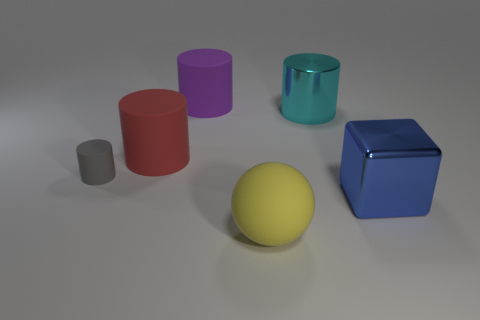Is there a big blue cube that has the same material as the large cyan cylinder?
Your answer should be very brief. Yes. The blue shiny object is what size?
Your answer should be compact. Large. What number of yellow objects are either large balls or tiny objects?
Make the answer very short. 1. What number of yellow rubber objects have the same shape as the red matte thing?
Ensure brevity in your answer.  0. How many green matte cylinders are the same size as the blue metal object?
Provide a succinct answer. 0. There is a purple object that is the same shape as the big red rubber object; what is its material?
Ensure brevity in your answer.  Rubber. There is a cylinder that is on the right side of the big purple thing; what color is it?
Provide a succinct answer. Cyan. Is the number of large shiny things behind the cyan object greater than the number of big red rubber cylinders?
Keep it short and to the point. No. What color is the big matte sphere?
Your response must be concise. Yellow. There is a metal object behind the big object that is on the right side of the cylinder that is on the right side of the purple object; what shape is it?
Provide a succinct answer. Cylinder. 